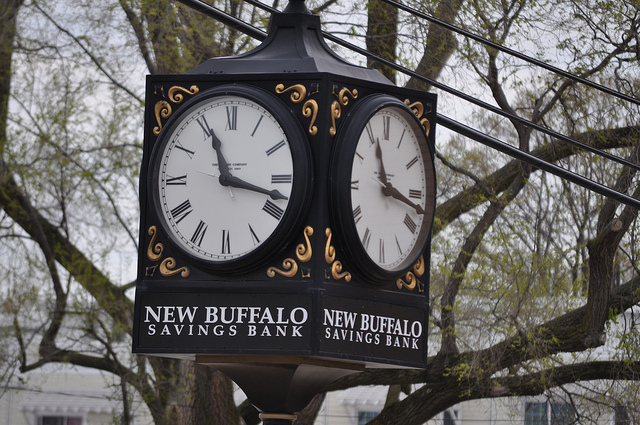Read all the text in this image. NEW SAVINGS BUFFALO BANK NEW SAVINGS BANK BUFFALO V III XL X IX IIA VI III i 